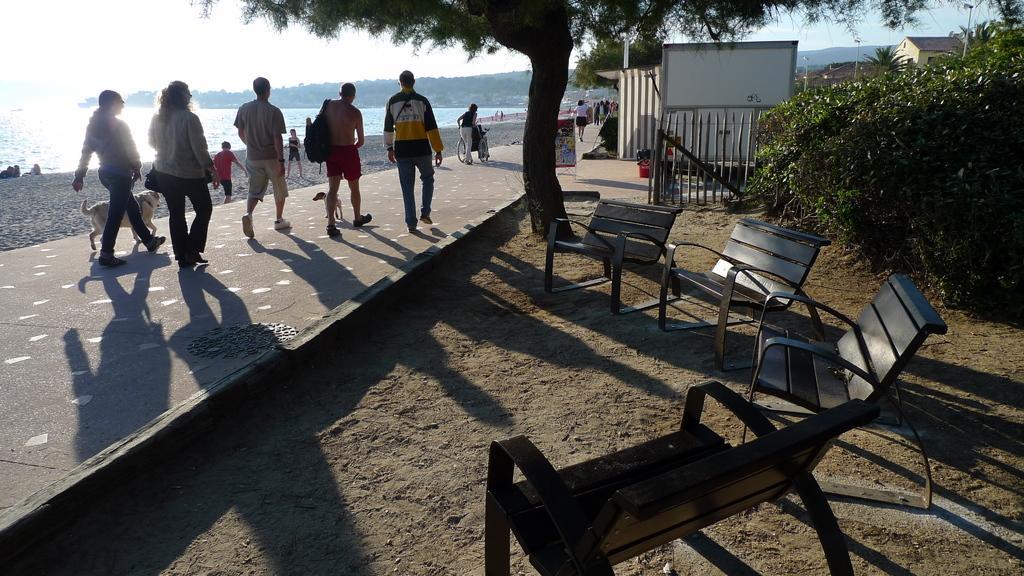Please provide a concise description of this image. In this image there are group of people , 2 dogs, walking in the street, there are benches in the sand , plants, house, sky, mountains, beach. 